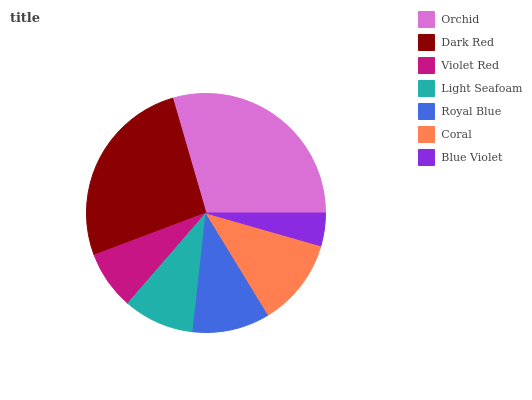Is Blue Violet the minimum?
Answer yes or no. Yes. Is Orchid the maximum?
Answer yes or no. Yes. Is Dark Red the minimum?
Answer yes or no. No. Is Dark Red the maximum?
Answer yes or no. No. Is Orchid greater than Dark Red?
Answer yes or no. Yes. Is Dark Red less than Orchid?
Answer yes or no. Yes. Is Dark Red greater than Orchid?
Answer yes or no. No. Is Orchid less than Dark Red?
Answer yes or no. No. Is Royal Blue the high median?
Answer yes or no. Yes. Is Royal Blue the low median?
Answer yes or no. Yes. Is Dark Red the high median?
Answer yes or no. No. Is Orchid the low median?
Answer yes or no. No. 